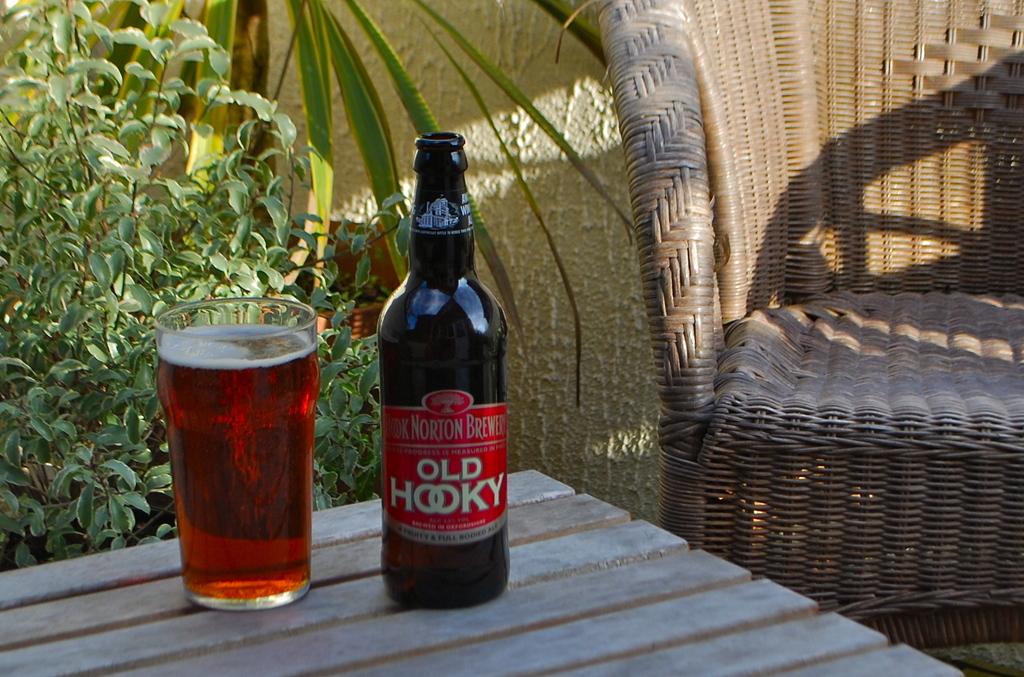What brewery did it come from?
Provide a succinct answer. Old hooky. 